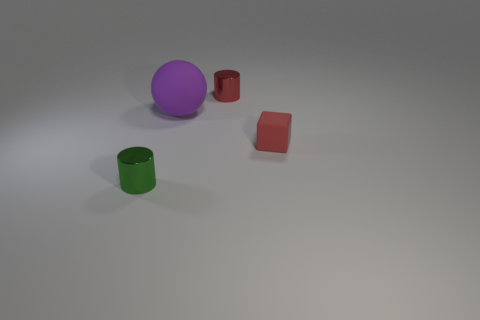How many things are either tiny metal cylinders that are right of the small green shiny cylinder or small metal things behind the large ball?
Provide a succinct answer. 1. Does the small rubber block have the same color as the large thing?
Offer a very short reply. No. Are there fewer purple metal cubes than green objects?
Offer a very short reply. Yes. Are there any tiny metal objects in front of the purple matte thing?
Your answer should be compact. Yes. Are the tiny green thing and the small red cube made of the same material?
Provide a short and direct response. No. What is the color of the other small metal object that is the same shape as the red metal thing?
Your answer should be very brief. Green. There is a thing that is on the left side of the large object; is its color the same as the small rubber cube?
Offer a very short reply. No. What shape is the metal object that is the same color as the matte block?
Make the answer very short. Cylinder. What number of other tiny things have the same material as the purple thing?
Ensure brevity in your answer.  1. There is a red shiny thing; what number of small cubes are behind it?
Provide a short and direct response. 0. 